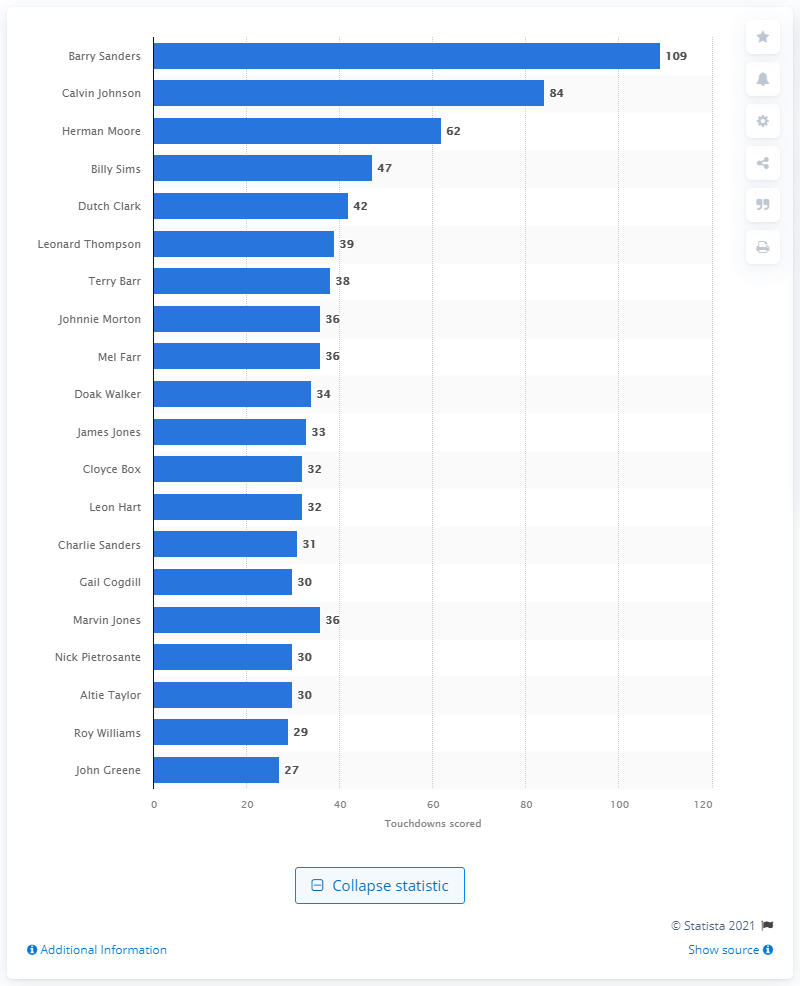Give some essential details in this illustration. The career touchdown leader of the Detroit Lions is Barry Sanders. 